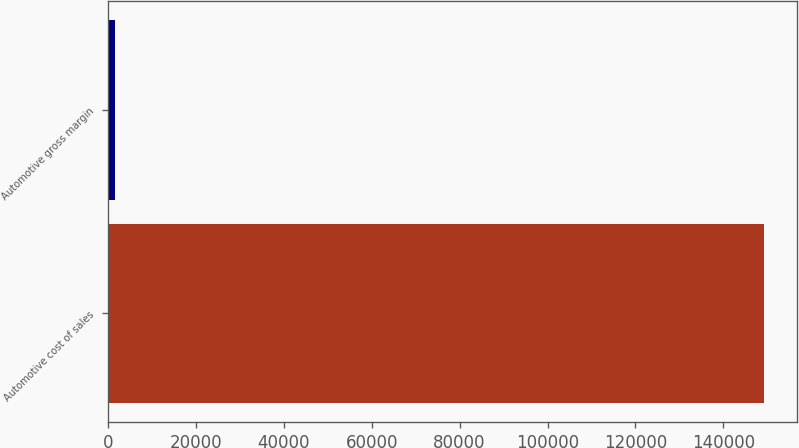<chart> <loc_0><loc_0><loc_500><loc_500><bar_chart><fcel>Automotive cost of sales<fcel>Automotive gross margin<nl><fcel>149257<fcel>1525<nl></chart> 